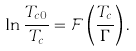Convert formula to latex. <formula><loc_0><loc_0><loc_500><loc_500>\ln \frac { T _ { c 0 } } { T _ { c } } = \mathcal { F } \left ( \frac { T _ { c } } { \Gamma } \right ) .</formula> 